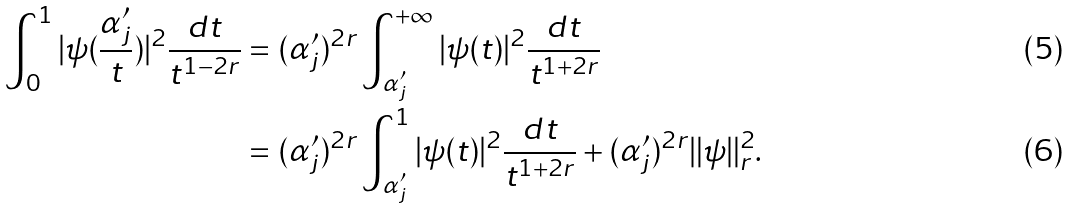<formula> <loc_0><loc_0><loc_500><loc_500>\int _ { 0 } ^ { 1 } | \psi ( \frac { \alpha ^ { \prime } _ { j } } { t } ) | ^ { 2 } \frac { d t } { t ^ { 1 - 2 r } } & = ( \alpha ^ { \prime } _ { j } ) ^ { 2 r } \int _ { \alpha ^ { \prime } _ { j } } ^ { + \infty } | \psi ( t ) | ^ { 2 } \frac { d t } { t ^ { 1 + 2 r } } \\ & = ( \alpha ^ { \prime } _ { j } ) ^ { 2 r } \int _ { \alpha ^ { \prime } _ { j } } ^ { 1 } | \psi ( t ) | ^ { 2 } \frac { d t } { t ^ { 1 + 2 r } } + ( \alpha ^ { \prime } _ { j } ) ^ { 2 r } \| \psi \| _ { r } ^ { 2 } .</formula> 